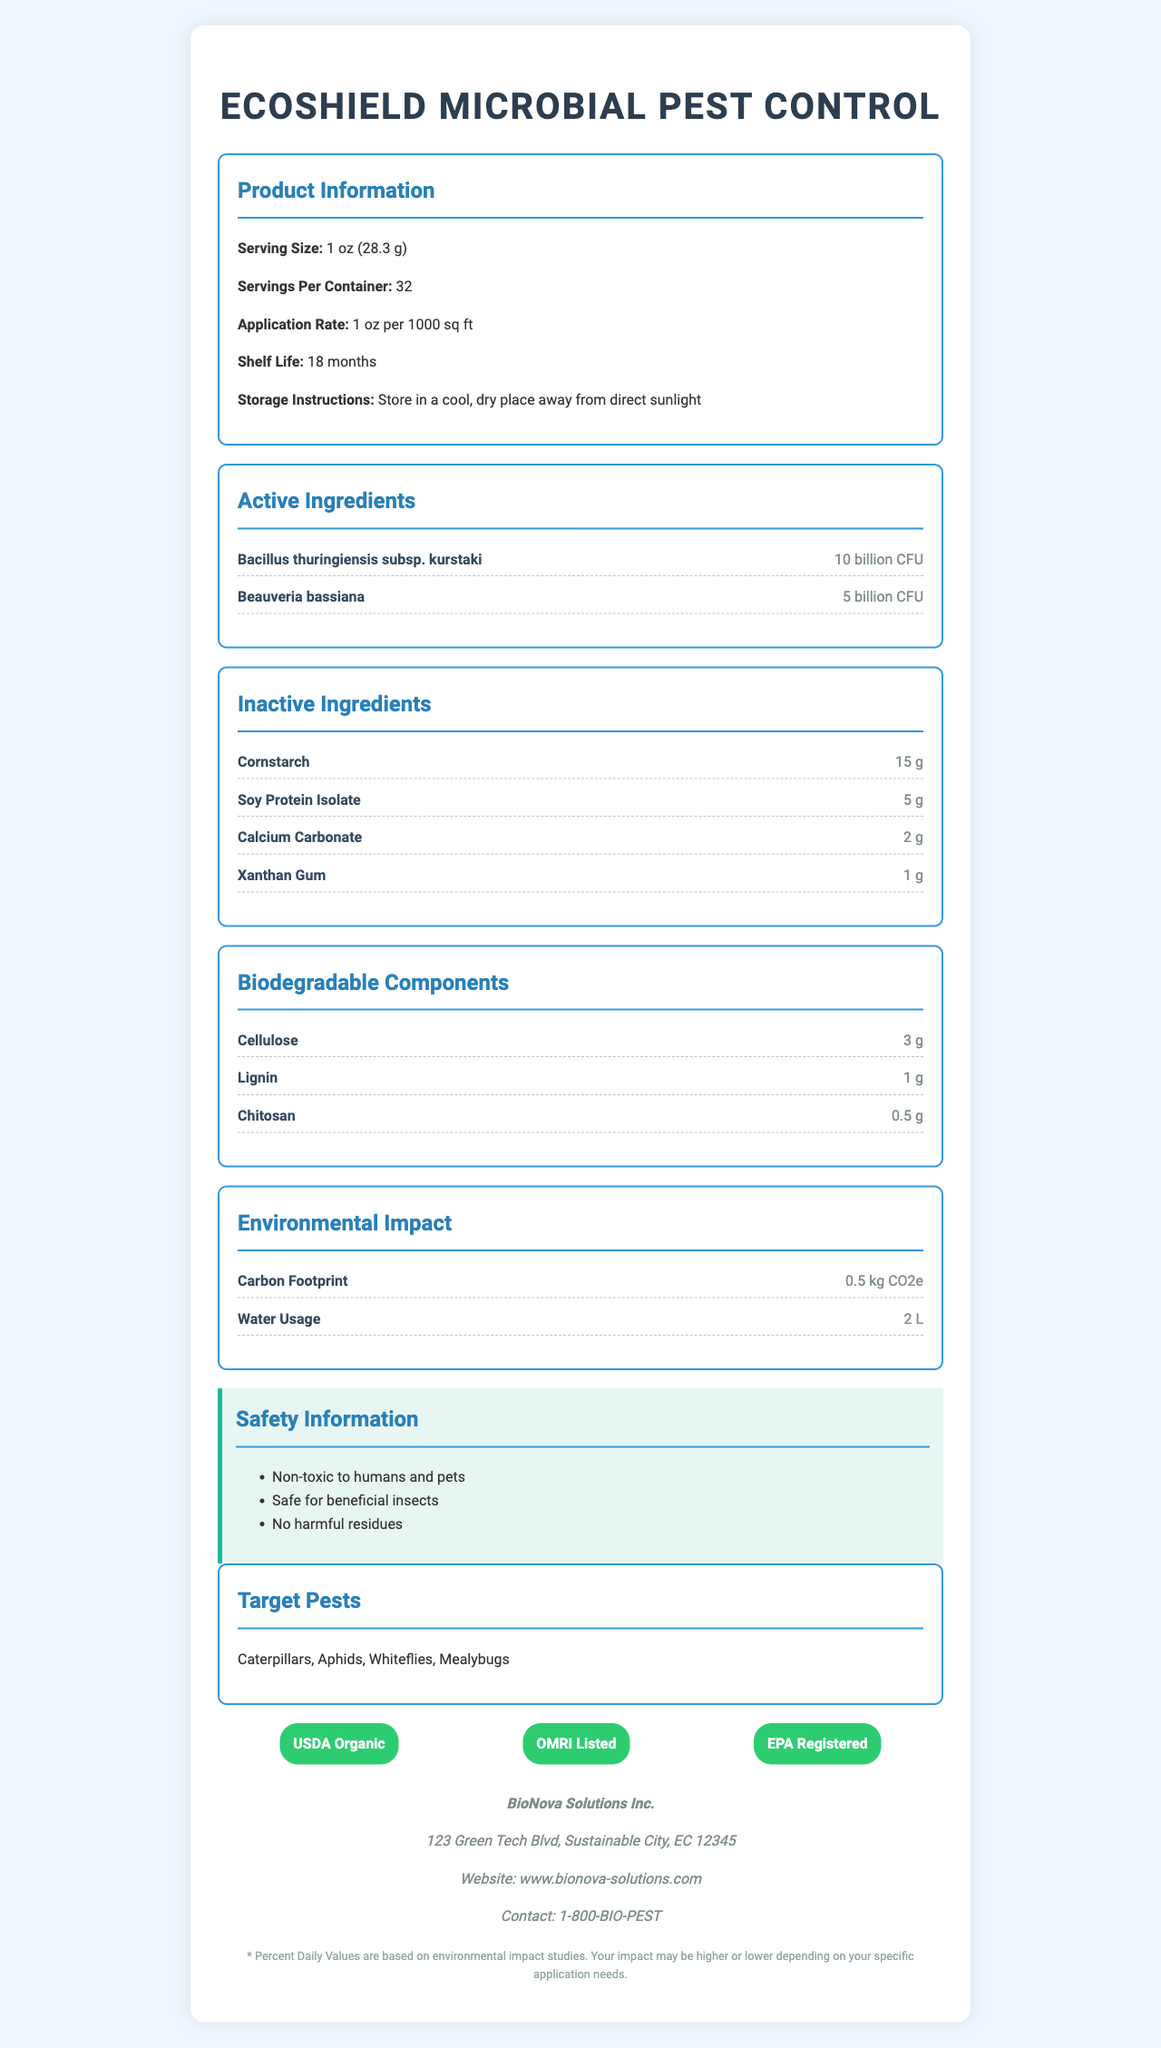what is the product name? The product name is mentioned at the top of the document as "EcoShield Microbial Pest Control".
Answer: EcoShield Microbial Pest Control what is the shelf life of the product? Shelf life is listed under the "Product Information" section as 18 months.
Answer: 18 months which ingredients are biodegradable? The biodegradable components are listed under the "Biodegradable Components" section as Cellulose, Lignin, and Chitosan.
Answer: Cellulose, Lignin, Chitosan what are the active ingredients and their amounts? The active ingredients and their amounts are listed under the "Active Ingredients" section.
Answer: Bacillus thuringiensis subsp. kurstaki: 10 billion CFU, Beauveria bassiana: 5 billion CFU what is the application rate? The application rate is mentioned under the "Product Information" section as 1 oz per 1000 sq ft.
Answer: 1 oz per 1000 sq ft what is the serving size? The serving size is provided under the "Product Information" section as 1 oz (28.3 g).
Answer: 1 oz (28.3 g) what ingredients are listed under inactive ingredients? The ingredients listed under inactive ingredients include Cornstarch, Soy Protein Isolate, Calcium Carbonate, and Xanthan Gum.
Answer: Cornstarch, Soy Protein Isolate, Calcium Carbonate, Xanthan Gum which pests does the product target? The product targets Caterpillars, Aphids, Whiteflies, and Mealybugs, as listed under the "Target Pests" section.
Answer: Caterpillars, Aphids, Whiteflies, Mealybugs how much Cornstarch is in each serving? Cornstarch is listed as an inactive ingredient with an amount of 15 g.
Answer: 15 g where is the manufacturer of the product located? The manufacturer’s address is provided in the "manufacturerInfo" section as 123 Green Tech Blvd, Sustainable City, EC 12345.
Answer: 123 Green Tech Blvd, Sustainable City, EC 12345 which of the following certifications does the product have? A. USDA Organic B. OMRI Listed C. EPA Registered D. All of the above The product is certified by USDA Organic, OMRI Listed, and EPA Registered, as listed under the "certifications" section.
Answer: D. All of the above what is the water usage for the product? A. 1 L B. 2 L C. 3 L D. 4 L The water usage is listed under the "Environmental Impact" section as 2 L.
Answer: B. 2 L is the product safe for beneficial insects? The safety information section mentions that the product is safe for beneficial insects.
Answer: Yes summarize the main components and features of the EcoShield Microbial Pest Control product. This summary captures the key details regarding the components, targeted pests, safety information, and certifications of the product.
Answer: EcoShield Microbial Pest Control is a biodegradable, microbial pesticide with active ingredients like Bacillus thuringiensis subsp. kurstaki and Beauveria bassiana. It is designed to target pests such as Caterpillars, Aphids, Whiteflies, and Mealybugs. The product includes inactive ingredients like Cornstarch and Soy Protein Isolate, along with biodegradable components like Cellulose. It has a shelf life of 18 months and requires 1 oz per 1000 sq ft for application. Safety features include being non-toxic to humans and pets, safe for beneficial insects, and leaving no harmful residues. The environmental impact includes a carbon footprint of 0.5 kg CO2e. It is certified USDA Organic, OMRI Listed, and EPA Registered. what is the environmental impact of the product? The environmental impact section lists the product's carbon footprint as 0.5 kg CO2e and water usage as 2 L.
Answer: 0.5 kg CO2e (Carbon Footprint), 2 L (Water Usage) what is the email address for BioNova Solutions Inc.? The document does not provide an email address for BioNova Solutions Inc., only a website and a contact phone number.
Answer: Not enough information 